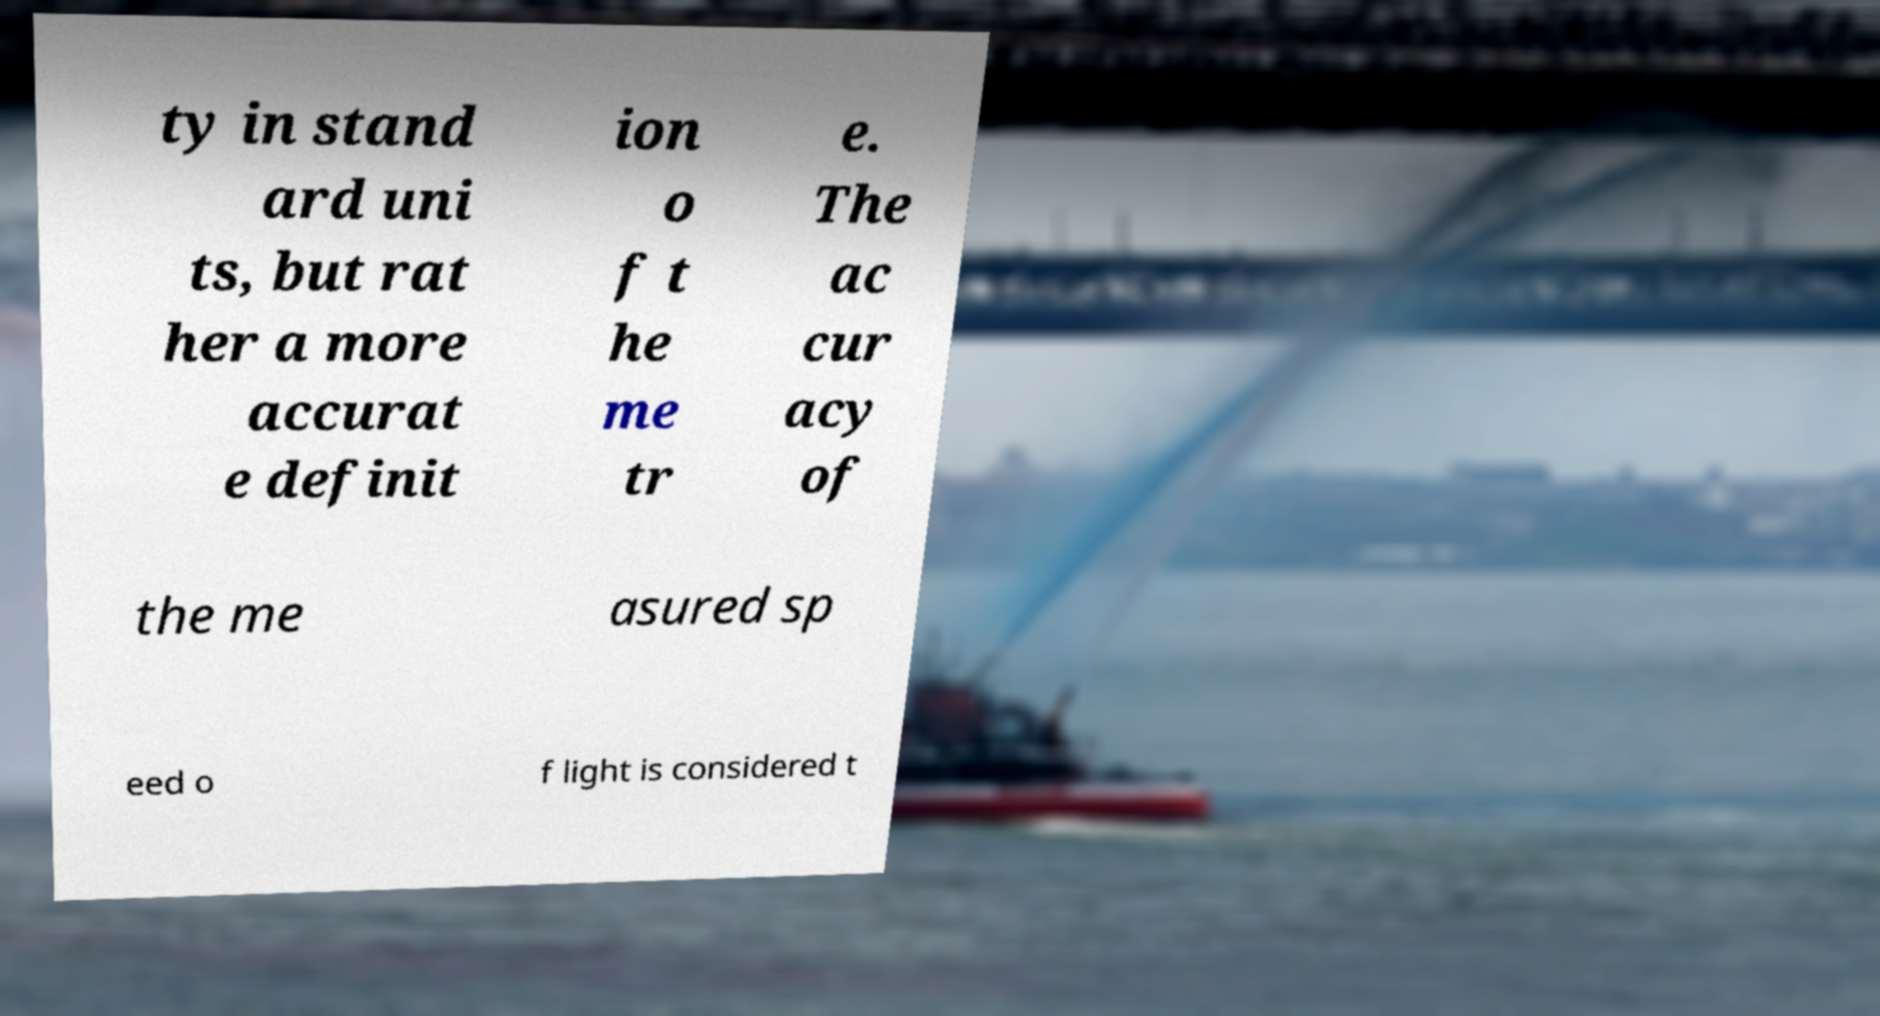There's text embedded in this image that I need extracted. Can you transcribe it verbatim? ty in stand ard uni ts, but rat her a more accurat e definit ion o f t he me tr e. The ac cur acy of the me asured sp eed o f light is considered t 